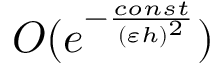Convert formula to latex. <formula><loc_0><loc_0><loc_500><loc_500>O ( e ^ { - \frac { c o n s t } { ( \varepsilon h ) ^ { 2 } } } )</formula> 